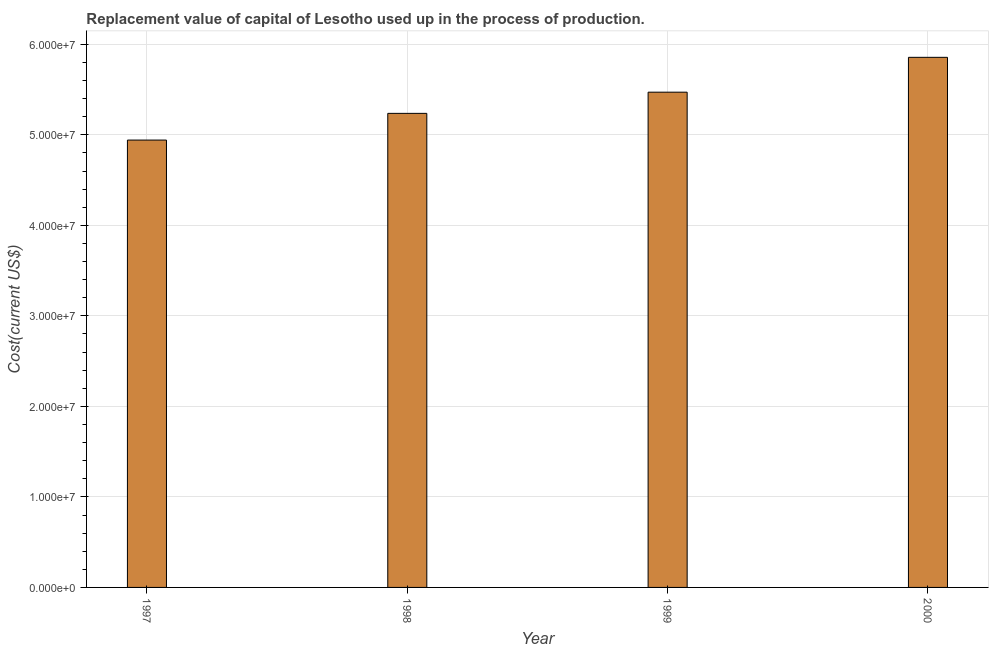Does the graph contain grids?
Make the answer very short. Yes. What is the title of the graph?
Give a very brief answer. Replacement value of capital of Lesotho used up in the process of production. What is the label or title of the Y-axis?
Ensure brevity in your answer.  Cost(current US$). What is the consumption of fixed capital in 2000?
Provide a short and direct response. 5.86e+07. Across all years, what is the maximum consumption of fixed capital?
Provide a succinct answer. 5.86e+07. Across all years, what is the minimum consumption of fixed capital?
Make the answer very short. 4.94e+07. In which year was the consumption of fixed capital minimum?
Give a very brief answer. 1997. What is the sum of the consumption of fixed capital?
Ensure brevity in your answer.  2.15e+08. What is the difference between the consumption of fixed capital in 1998 and 2000?
Make the answer very short. -6.19e+06. What is the average consumption of fixed capital per year?
Provide a short and direct response. 5.38e+07. What is the median consumption of fixed capital?
Ensure brevity in your answer.  5.35e+07. In how many years, is the consumption of fixed capital greater than 54000000 US$?
Your answer should be compact. 2. Do a majority of the years between 1999 and 1998 (inclusive) have consumption of fixed capital greater than 52000000 US$?
Offer a very short reply. No. What is the ratio of the consumption of fixed capital in 1997 to that in 2000?
Provide a succinct answer. 0.84. Is the difference between the consumption of fixed capital in 1999 and 2000 greater than the difference between any two years?
Offer a very short reply. No. What is the difference between the highest and the second highest consumption of fixed capital?
Your answer should be compact. 3.85e+06. What is the difference between the highest and the lowest consumption of fixed capital?
Your response must be concise. 9.14e+06. How many bars are there?
Provide a succinct answer. 4. What is the Cost(current US$) of 1997?
Provide a succinct answer. 4.94e+07. What is the Cost(current US$) in 1998?
Provide a short and direct response. 5.24e+07. What is the Cost(current US$) in 1999?
Your answer should be very brief. 5.47e+07. What is the Cost(current US$) of 2000?
Your answer should be very brief. 5.86e+07. What is the difference between the Cost(current US$) in 1997 and 1998?
Your answer should be very brief. -2.95e+06. What is the difference between the Cost(current US$) in 1997 and 1999?
Give a very brief answer. -5.29e+06. What is the difference between the Cost(current US$) in 1997 and 2000?
Make the answer very short. -9.14e+06. What is the difference between the Cost(current US$) in 1998 and 1999?
Your answer should be compact. -2.34e+06. What is the difference between the Cost(current US$) in 1998 and 2000?
Offer a very short reply. -6.19e+06. What is the difference between the Cost(current US$) in 1999 and 2000?
Your answer should be compact. -3.85e+06. What is the ratio of the Cost(current US$) in 1997 to that in 1998?
Make the answer very short. 0.94. What is the ratio of the Cost(current US$) in 1997 to that in 1999?
Your answer should be very brief. 0.9. What is the ratio of the Cost(current US$) in 1997 to that in 2000?
Provide a short and direct response. 0.84. What is the ratio of the Cost(current US$) in 1998 to that in 2000?
Your response must be concise. 0.89. What is the ratio of the Cost(current US$) in 1999 to that in 2000?
Ensure brevity in your answer.  0.93. 